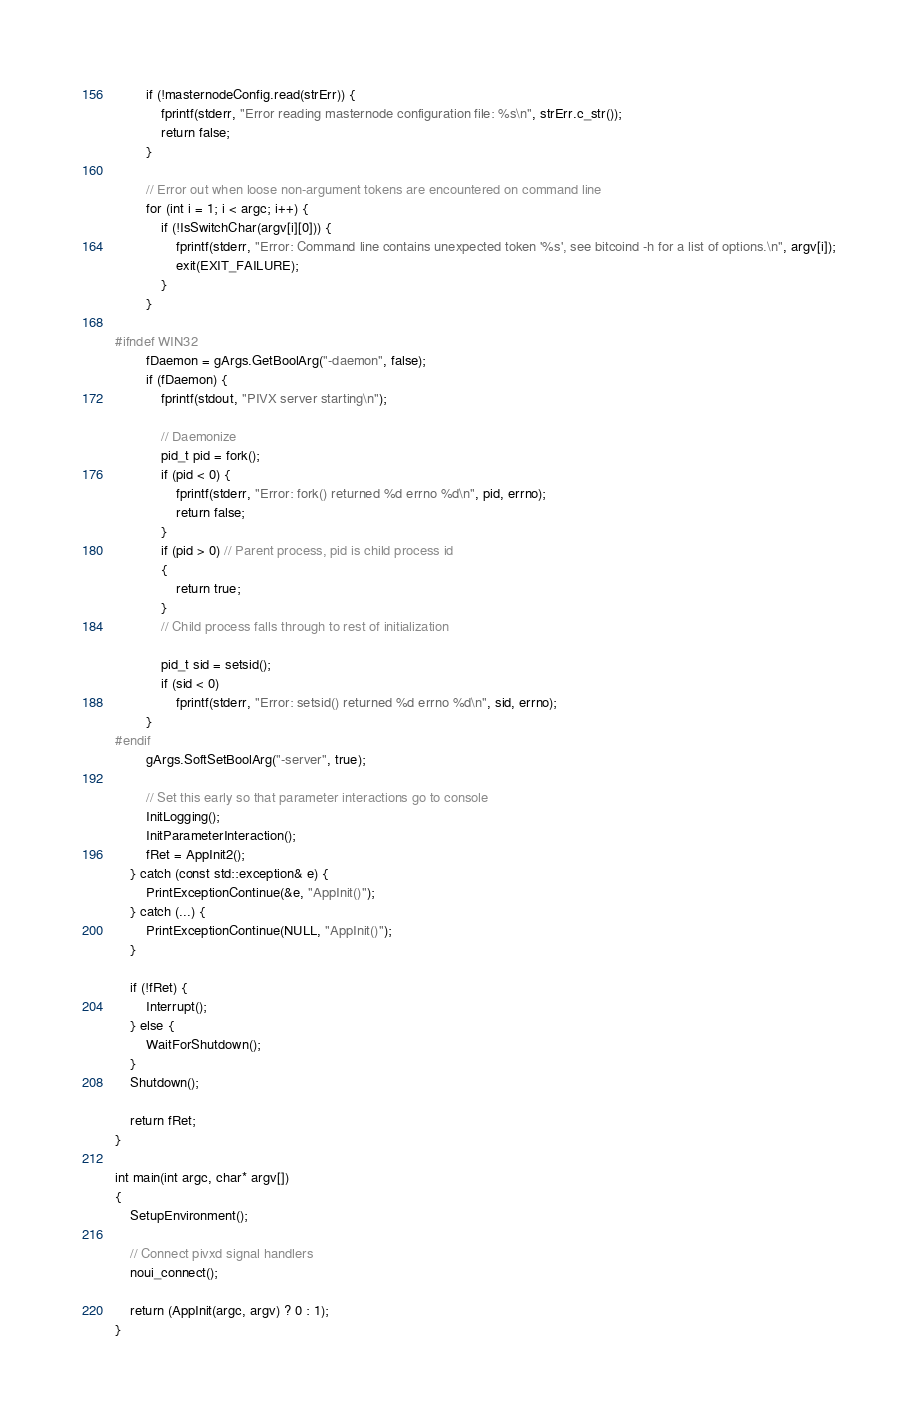Convert code to text. <code><loc_0><loc_0><loc_500><loc_500><_C++_>        if (!masternodeConfig.read(strErr)) {
            fprintf(stderr, "Error reading masternode configuration file: %s\n", strErr.c_str());
            return false;
        }

        // Error out when loose non-argument tokens are encountered on command line
        for (int i = 1; i < argc; i++) {
            if (!IsSwitchChar(argv[i][0])) {
                fprintf(stderr, "Error: Command line contains unexpected token '%s', see bitcoind -h for a list of options.\n", argv[i]);
                exit(EXIT_FAILURE);
            }
        }

#ifndef WIN32
        fDaemon = gArgs.GetBoolArg("-daemon", false);
        if (fDaemon) {
            fprintf(stdout, "PIVX server starting\n");

            // Daemonize
            pid_t pid = fork();
            if (pid < 0) {
                fprintf(stderr, "Error: fork() returned %d errno %d\n", pid, errno);
                return false;
            }
            if (pid > 0) // Parent process, pid is child process id
            {
                return true;
            }
            // Child process falls through to rest of initialization

            pid_t sid = setsid();
            if (sid < 0)
                fprintf(stderr, "Error: setsid() returned %d errno %d\n", sid, errno);
        }
#endif
        gArgs.SoftSetBoolArg("-server", true);

        // Set this early so that parameter interactions go to console
        InitLogging();
        InitParameterInteraction();
        fRet = AppInit2();
    } catch (const std::exception& e) {
        PrintExceptionContinue(&e, "AppInit()");
    } catch (...) {
        PrintExceptionContinue(NULL, "AppInit()");
    }

    if (!fRet) {
        Interrupt();
    } else {
        WaitForShutdown();
    }
    Shutdown();

    return fRet;
}

int main(int argc, char* argv[])
{
    SetupEnvironment();

    // Connect pivxd signal handlers
    noui_connect();

    return (AppInit(argc, argv) ? 0 : 1);
}
</code> 